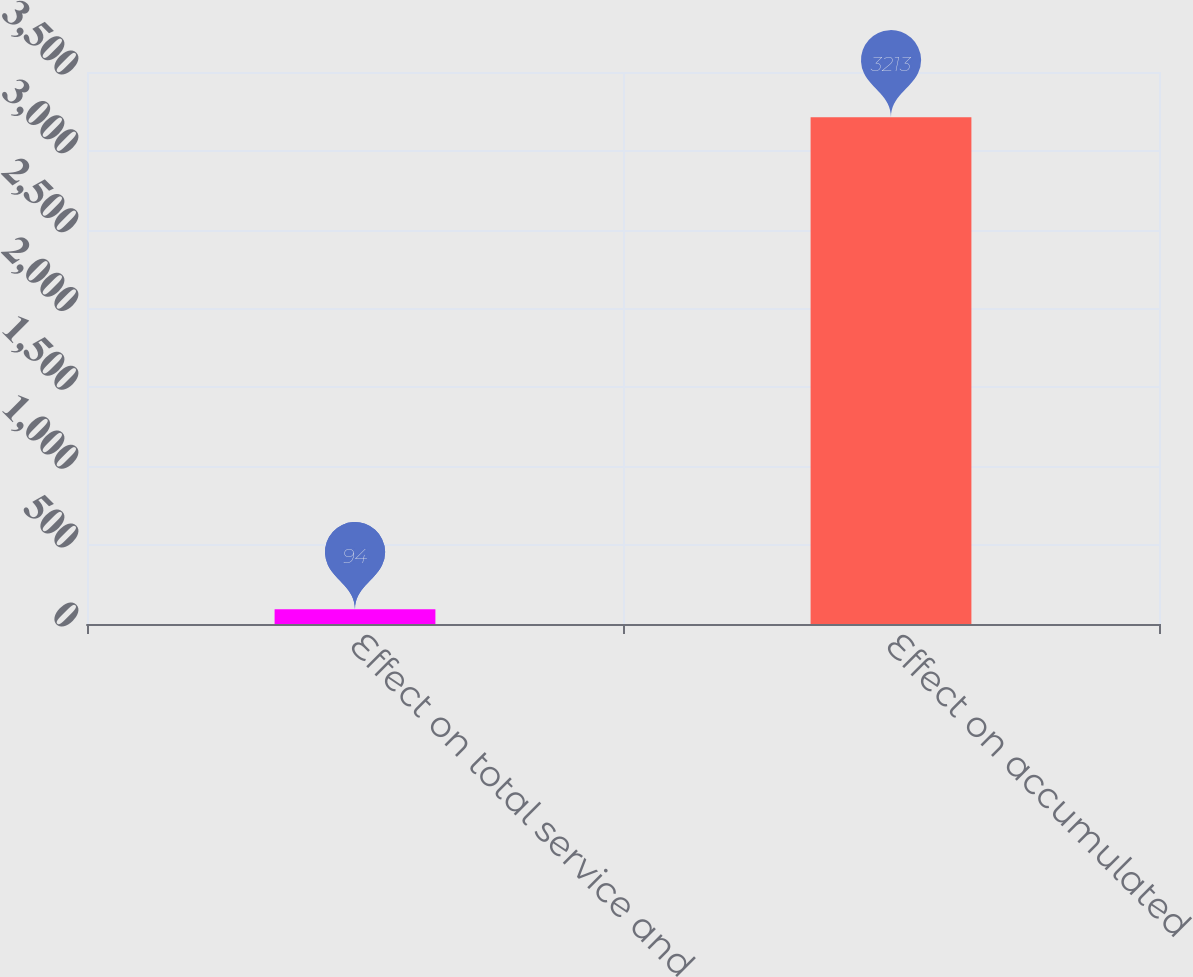Convert chart to OTSL. <chart><loc_0><loc_0><loc_500><loc_500><bar_chart><fcel>Effect on total service and<fcel>Effect on accumulated<nl><fcel>94<fcel>3213<nl></chart> 